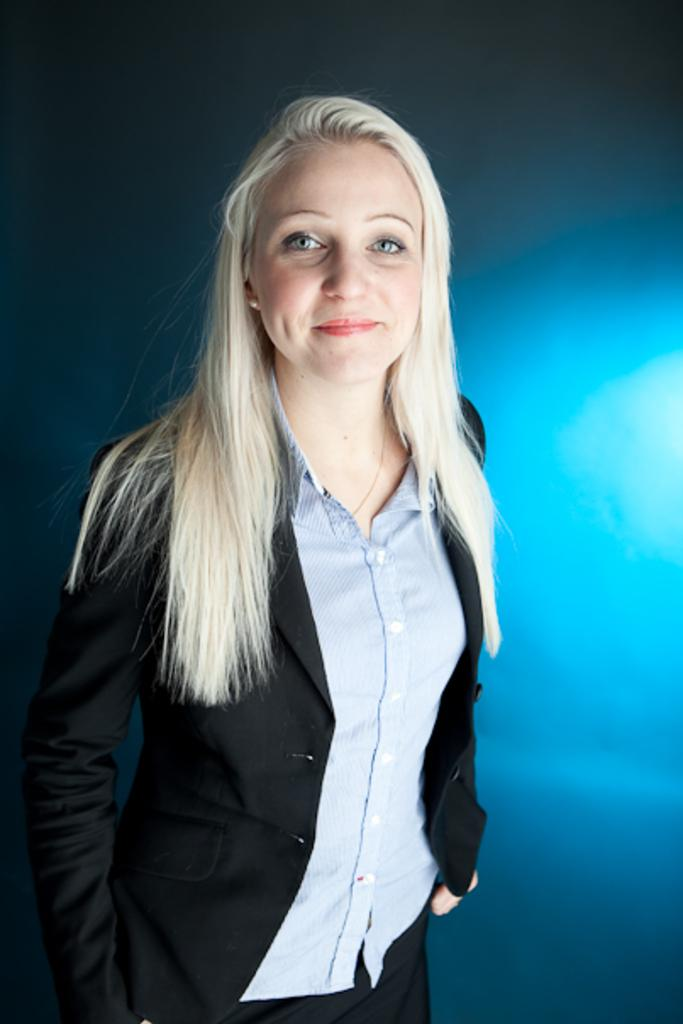Who is the main subject in the image? There is a woman in the image. What is the woman doing in the image? The woman is standing and giving a pose for the picture. What is the woman's facial expression in the image? The woman is smiling in the image. Can you describe the background of the image? The background of the image may have been edited. What color is the minister's robe in the image? There is no minister or robe present in the image; it features a woman standing and smiling. 